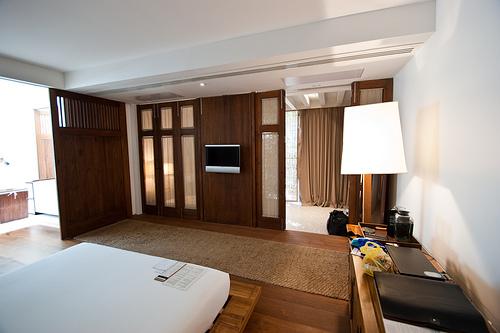Are the lights on?
Keep it brief. Yes. Is this a hotel room?
Concise answer only. Yes. Does the room have curtains?
Short answer required. Yes. Are they remodeling this area?
Give a very brief answer. No. Is there a tv on the wall?
Give a very brief answer. Yes. 